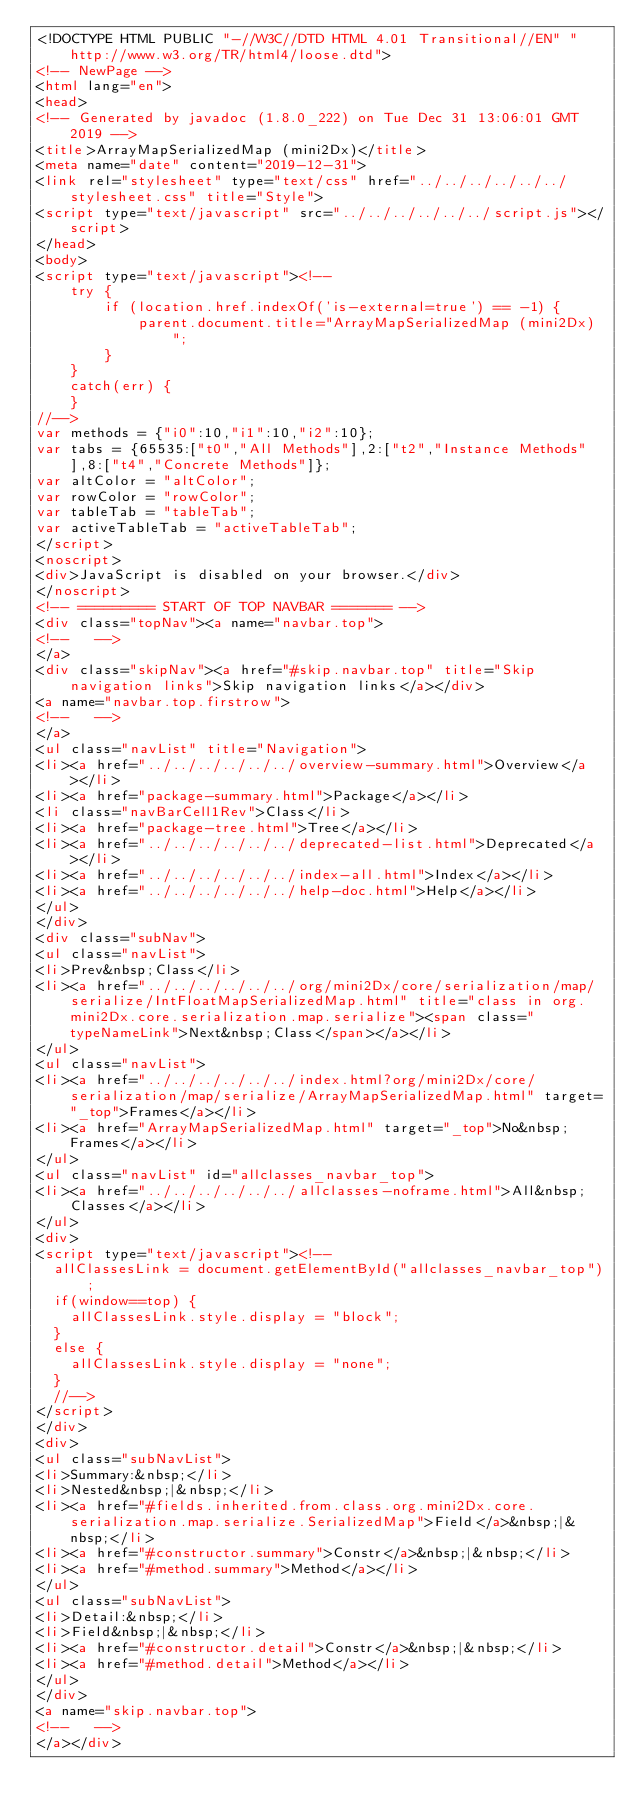<code> <loc_0><loc_0><loc_500><loc_500><_HTML_><!DOCTYPE HTML PUBLIC "-//W3C//DTD HTML 4.01 Transitional//EN" "http://www.w3.org/TR/html4/loose.dtd">
<!-- NewPage -->
<html lang="en">
<head>
<!-- Generated by javadoc (1.8.0_222) on Tue Dec 31 13:06:01 GMT 2019 -->
<title>ArrayMapSerializedMap (mini2Dx)</title>
<meta name="date" content="2019-12-31">
<link rel="stylesheet" type="text/css" href="../../../../../../stylesheet.css" title="Style">
<script type="text/javascript" src="../../../../../../script.js"></script>
</head>
<body>
<script type="text/javascript"><!--
    try {
        if (location.href.indexOf('is-external=true') == -1) {
            parent.document.title="ArrayMapSerializedMap (mini2Dx)";
        }
    }
    catch(err) {
    }
//-->
var methods = {"i0":10,"i1":10,"i2":10};
var tabs = {65535:["t0","All Methods"],2:["t2","Instance Methods"],8:["t4","Concrete Methods"]};
var altColor = "altColor";
var rowColor = "rowColor";
var tableTab = "tableTab";
var activeTableTab = "activeTableTab";
</script>
<noscript>
<div>JavaScript is disabled on your browser.</div>
</noscript>
<!-- ========= START OF TOP NAVBAR ======= -->
<div class="topNav"><a name="navbar.top">
<!--   -->
</a>
<div class="skipNav"><a href="#skip.navbar.top" title="Skip navigation links">Skip navigation links</a></div>
<a name="navbar.top.firstrow">
<!--   -->
</a>
<ul class="navList" title="Navigation">
<li><a href="../../../../../../overview-summary.html">Overview</a></li>
<li><a href="package-summary.html">Package</a></li>
<li class="navBarCell1Rev">Class</li>
<li><a href="package-tree.html">Tree</a></li>
<li><a href="../../../../../../deprecated-list.html">Deprecated</a></li>
<li><a href="../../../../../../index-all.html">Index</a></li>
<li><a href="../../../../../../help-doc.html">Help</a></li>
</ul>
</div>
<div class="subNav">
<ul class="navList">
<li>Prev&nbsp;Class</li>
<li><a href="../../../../../../org/mini2Dx/core/serialization/map/serialize/IntFloatMapSerializedMap.html" title="class in org.mini2Dx.core.serialization.map.serialize"><span class="typeNameLink">Next&nbsp;Class</span></a></li>
</ul>
<ul class="navList">
<li><a href="../../../../../../index.html?org/mini2Dx/core/serialization/map/serialize/ArrayMapSerializedMap.html" target="_top">Frames</a></li>
<li><a href="ArrayMapSerializedMap.html" target="_top">No&nbsp;Frames</a></li>
</ul>
<ul class="navList" id="allclasses_navbar_top">
<li><a href="../../../../../../allclasses-noframe.html">All&nbsp;Classes</a></li>
</ul>
<div>
<script type="text/javascript"><!--
  allClassesLink = document.getElementById("allclasses_navbar_top");
  if(window==top) {
    allClassesLink.style.display = "block";
  }
  else {
    allClassesLink.style.display = "none";
  }
  //-->
</script>
</div>
<div>
<ul class="subNavList">
<li>Summary:&nbsp;</li>
<li>Nested&nbsp;|&nbsp;</li>
<li><a href="#fields.inherited.from.class.org.mini2Dx.core.serialization.map.serialize.SerializedMap">Field</a>&nbsp;|&nbsp;</li>
<li><a href="#constructor.summary">Constr</a>&nbsp;|&nbsp;</li>
<li><a href="#method.summary">Method</a></li>
</ul>
<ul class="subNavList">
<li>Detail:&nbsp;</li>
<li>Field&nbsp;|&nbsp;</li>
<li><a href="#constructor.detail">Constr</a>&nbsp;|&nbsp;</li>
<li><a href="#method.detail">Method</a></li>
</ul>
</div>
<a name="skip.navbar.top">
<!--   -->
</a></div></code> 